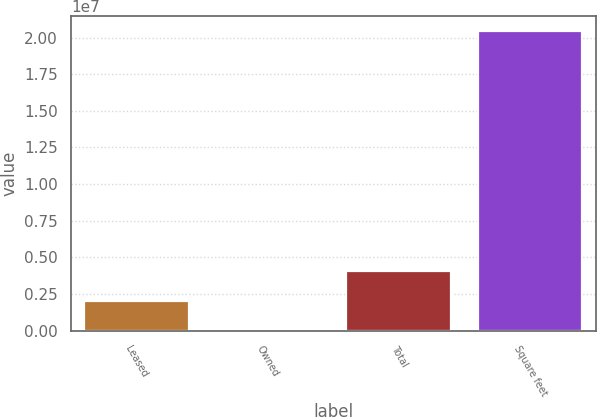<chart> <loc_0><loc_0><loc_500><loc_500><bar_chart><fcel>Leased<fcel>Owned<fcel>Total<fcel>Square feet<nl><fcel>2.0463e+06<fcel>71<fcel>4.09254e+06<fcel>2.04624e+07<nl></chart> 